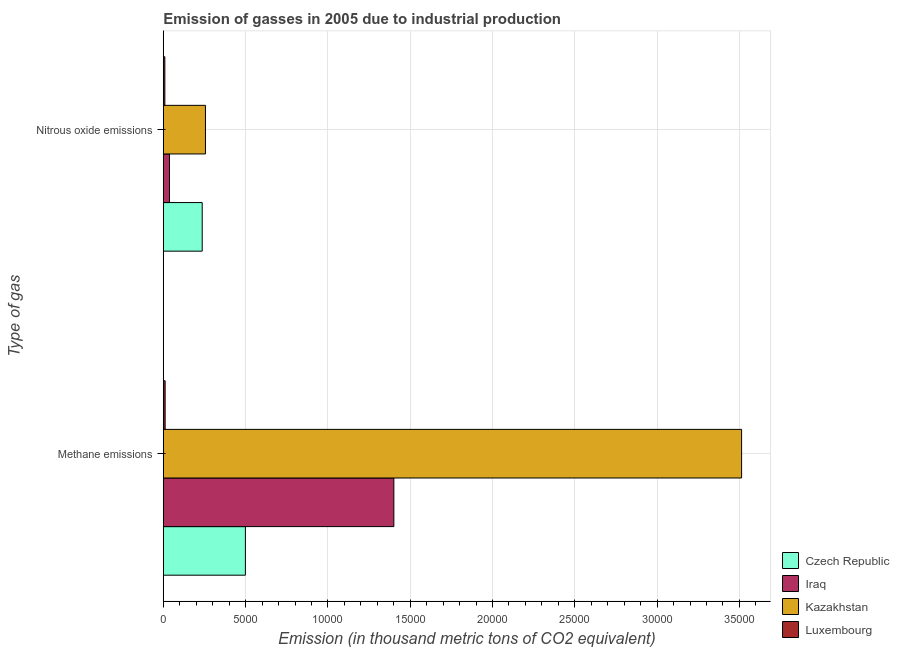How many different coloured bars are there?
Provide a short and direct response. 4. Are the number of bars per tick equal to the number of legend labels?
Keep it short and to the point. Yes. How many bars are there on the 1st tick from the bottom?
Your answer should be compact. 4. What is the label of the 2nd group of bars from the top?
Your response must be concise. Methane emissions. What is the amount of nitrous oxide emissions in Kazakhstan?
Offer a very short reply. 2561.2. Across all countries, what is the maximum amount of nitrous oxide emissions?
Offer a very short reply. 2561.2. Across all countries, what is the minimum amount of nitrous oxide emissions?
Keep it short and to the point. 93.4. In which country was the amount of methane emissions maximum?
Offer a terse response. Kazakhstan. In which country was the amount of nitrous oxide emissions minimum?
Offer a very short reply. Luxembourg. What is the total amount of methane emissions in the graph?
Give a very brief answer. 5.42e+04. What is the difference between the amount of nitrous oxide emissions in Kazakhstan and that in Luxembourg?
Ensure brevity in your answer.  2467.8. What is the difference between the amount of methane emissions in Czech Republic and the amount of nitrous oxide emissions in Kazakhstan?
Make the answer very short. 2425.7. What is the average amount of nitrous oxide emissions per country?
Provide a succinct answer. 1348.65. What is the difference between the amount of nitrous oxide emissions and amount of methane emissions in Czech Republic?
Offer a very short reply. -2622.4. In how many countries, is the amount of nitrous oxide emissions greater than 33000 thousand metric tons?
Ensure brevity in your answer.  0. What is the ratio of the amount of nitrous oxide emissions in Iraq to that in Kazakhstan?
Give a very brief answer. 0.15. Is the amount of nitrous oxide emissions in Kazakhstan less than that in Luxembourg?
Give a very brief answer. No. What does the 4th bar from the top in Nitrous oxide emissions represents?
Offer a terse response. Czech Republic. What does the 2nd bar from the bottom in Nitrous oxide emissions represents?
Your answer should be compact. Iraq. What is the difference between two consecutive major ticks on the X-axis?
Provide a succinct answer. 5000. Are the values on the major ticks of X-axis written in scientific E-notation?
Give a very brief answer. No. Does the graph contain any zero values?
Give a very brief answer. No. Where does the legend appear in the graph?
Offer a terse response. Bottom right. How many legend labels are there?
Ensure brevity in your answer.  4. How are the legend labels stacked?
Make the answer very short. Vertical. What is the title of the graph?
Offer a terse response. Emission of gasses in 2005 due to industrial production. Does "Somalia" appear as one of the legend labels in the graph?
Make the answer very short. No. What is the label or title of the X-axis?
Your answer should be compact. Emission (in thousand metric tons of CO2 equivalent). What is the label or title of the Y-axis?
Offer a terse response. Type of gas. What is the Emission (in thousand metric tons of CO2 equivalent) of Czech Republic in Methane emissions?
Keep it short and to the point. 4986.9. What is the Emission (in thousand metric tons of CO2 equivalent) of Iraq in Methane emissions?
Your response must be concise. 1.40e+04. What is the Emission (in thousand metric tons of CO2 equivalent) of Kazakhstan in Methane emissions?
Your answer should be compact. 3.51e+04. What is the Emission (in thousand metric tons of CO2 equivalent) of Luxembourg in Methane emissions?
Make the answer very short. 111.5. What is the Emission (in thousand metric tons of CO2 equivalent) of Czech Republic in Nitrous oxide emissions?
Offer a very short reply. 2364.5. What is the Emission (in thousand metric tons of CO2 equivalent) of Iraq in Nitrous oxide emissions?
Your response must be concise. 375.5. What is the Emission (in thousand metric tons of CO2 equivalent) in Kazakhstan in Nitrous oxide emissions?
Provide a succinct answer. 2561.2. What is the Emission (in thousand metric tons of CO2 equivalent) in Luxembourg in Nitrous oxide emissions?
Provide a succinct answer. 93.4. Across all Type of gas, what is the maximum Emission (in thousand metric tons of CO2 equivalent) of Czech Republic?
Offer a very short reply. 4986.9. Across all Type of gas, what is the maximum Emission (in thousand metric tons of CO2 equivalent) in Iraq?
Offer a terse response. 1.40e+04. Across all Type of gas, what is the maximum Emission (in thousand metric tons of CO2 equivalent) in Kazakhstan?
Make the answer very short. 3.51e+04. Across all Type of gas, what is the maximum Emission (in thousand metric tons of CO2 equivalent) in Luxembourg?
Offer a terse response. 111.5. Across all Type of gas, what is the minimum Emission (in thousand metric tons of CO2 equivalent) of Czech Republic?
Your answer should be very brief. 2364.5. Across all Type of gas, what is the minimum Emission (in thousand metric tons of CO2 equivalent) in Iraq?
Your answer should be compact. 375.5. Across all Type of gas, what is the minimum Emission (in thousand metric tons of CO2 equivalent) of Kazakhstan?
Offer a terse response. 2561.2. Across all Type of gas, what is the minimum Emission (in thousand metric tons of CO2 equivalent) in Luxembourg?
Make the answer very short. 93.4. What is the total Emission (in thousand metric tons of CO2 equivalent) of Czech Republic in the graph?
Your response must be concise. 7351.4. What is the total Emission (in thousand metric tons of CO2 equivalent) of Iraq in the graph?
Make the answer very short. 1.44e+04. What is the total Emission (in thousand metric tons of CO2 equivalent) in Kazakhstan in the graph?
Offer a terse response. 3.77e+04. What is the total Emission (in thousand metric tons of CO2 equivalent) of Luxembourg in the graph?
Make the answer very short. 204.9. What is the difference between the Emission (in thousand metric tons of CO2 equivalent) in Czech Republic in Methane emissions and that in Nitrous oxide emissions?
Offer a terse response. 2622.4. What is the difference between the Emission (in thousand metric tons of CO2 equivalent) of Iraq in Methane emissions and that in Nitrous oxide emissions?
Your answer should be compact. 1.36e+04. What is the difference between the Emission (in thousand metric tons of CO2 equivalent) of Kazakhstan in Methane emissions and that in Nitrous oxide emissions?
Offer a very short reply. 3.26e+04. What is the difference between the Emission (in thousand metric tons of CO2 equivalent) in Czech Republic in Methane emissions and the Emission (in thousand metric tons of CO2 equivalent) in Iraq in Nitrous oxide emissions?
Your response must be concise. 4611.4. What is the difference between the Emission (in thousand metric tons of CO2 equivalent) of Czech Republic in Methane emissions and the Emission (in thousand metric tons of CO2 equivalent) of Kazakhstan in Nitrous oxide emissions?
Provide a short and direct response. 2425.7. What is the difference between the Emission (in thousand metric tons of CO2 equivalent) in Czech Republic in Methane emissions and the Emission (in thousand metric tons of CO2 equivalent) in Luxembourg in Nitrous oxide emissions?
Provide a succinct answer. 4893.5. What is the difference between the Emission (in thousand metric tons of CO2 equivalent) of Iraq in Methane emissions and the Emission (in thousand metric tons of CO2 equivalent) of Kazakhstan in Nitrous oxide emissions?
Provide a short and direct response. 1.14e+04. What is the difference between the Emission (in thousand metric tons of CO2 equivalent) in Iraq in Methane emissions and the Emission (in thousand metric tons of CO2 equivalent) in Luxembourg in Nitrous oxide emissions?
Your answer should be very brief. 1.39e+04. What is the difference between the Emission (in thousand metric tons of CO2 equivalent) in Kazakhstan in Methane emissions and the Emission (in thousand metric tons of CO2 equivalent) in Luxembourg in Nitrous oxide emissions?
Your answer should be compact. 3.50e+04. What is the average Emission (in thousand metric tons of CO2 equivalent) of Czech Republic per Type of gas?
Your answer should be very brief. 3675.7. What is the average Emission (in thousand metric tons of CO2 equivalent) of Iraq per Type of gas?
Provide a succinct answer. 7190.6. What is the average Emission (in thousand metric tons of CO2 equivalent) in Kazakhstan per Type of gas?
Provide a short and direct response. 1.88e+04. What is the average Emission (in thousand metric tons of CO2 equivalent) of Luxembourg per Type of gas?
Your answer should be compact. 102.45. What is the difference between the Emission (in thousand metric tons of CO2 equivalent) in Czech Republic and Emission (in thousand metric tons of CO2 equivalent) in Iraq in Methane emissions?
Ensure brevity in your answer.  -9018.8. What is the difference between the Emission (in thousand metric tons of CO2 equivalent) of Czech Republic and Emission (in thousand metric tons of CO2 equivalent) of Kazakhstan in Methane emissions?
Provide a succinct answer. -3.01e+04. What is the difference between the Emission (in thousand metric tons of CO2 equivalent) of Czech Republic and Emission (in thousand metric tons of CO2 equivalent) of Luxembourg in Methane emissions?
Provide a succinct answer. 4875.4. What is the difference between the Emission (in thousand metric tons of CO2 equivalent) in Iraq and Emission (in thousand metric tons of CO2 equivalent) in Kazakhstan in Methane emissions?
Your answer should be compact. -2.11e+04. What is the difference between the Emission (in thousand metric tons of CO2 equivalent) of Iraq and Emission (in thousand metric tons of CO2 equivalent) of Luxembourg in Methane emissions?
Your answer should be very brief. 1.39e+04. What is the difference between the Emission (in thousand metric tons of CO2 equivalent) in Kazakhstan and Emission (in thousand metric tons of CO2 equivalent) in Luxembourg in Methane emissions?
Make the answer very short. 3.50e+04. What is the difference between the Emission (in thousand metric tons of CO2 equivalent) in Czech Republic and Emission (in thousand metric tons of CO2 equivalent) in Iraq in Nitrous oxide emissions?
Your answer should be compact. 1989. What is the difference between the Emission (in thousand metric tons of CO2 equivalent) in Czech Republic and Emission (in thousand metric tons of CO2 equivalent) in Kazakhstan in Nitrous oxide emissions?
Your answer should be very brief. -196.7. What is the difference between the Emission (in thousand metric tons of CO2 equivalent) of Czech Republic and Emission (in thousand metric tons of CO2 equivalent) of Luxembourg in Nitrous oxide emissions?
Give a very brief answer. 2271.1. What is the difference between the Emission (in thousand metric tons of CO2 equivalent) in Iraq and Emission (in thousand metric tons of CO2 equivalent) in Kazakhstan in Nitrous oxide emissions?
Offer a terse response. -2185.7. What is the difference between the Emission (in thousand metric tons of CO2 equivalent) of Iraq and Emission (in thousand metric tons of CO2 equivalent) of Luxembourg in Nitrous oxide emissions?
Your answer should be very brief. 282.1. What is the difference between the Emission (in thousand metric tons of CO2 equivalent) in Kazakhstan and Emission (in thousand metric tons of CO2 equivalent) in Luxembourg in Nitrous oxide emissions?
Your answer should be compact. 2467.8. What is the ratio of the Emission (in thousand metric tons of CO2 equivalent) of Czech Republic in Methane emissions to that in Nitrous oxide emissions?
Ensure brevity in your answer.  2.11. What is the ratio of the Emission (in thousand metric tons of CO2 equivalent) of Iraq in Methane emissions to that in Nitrous oxide emissions?
Provide a succinct answer. 37.3. What is the ratio of the Emission (in thousand metric tons of CO2 equivalent) of Kazakhstan in Methane emissions to that in Nitrous oxide emissions?
Your response must be concise. 13.72. What is the ratio of the Emission (in thousand metric tons of CO2 equivalent) in Luxembourg in Methane emissions to that in Nitrous oxide emissions?
Ensure brevity in your answer.  1.19. What is the difference between the highest and the second highest Emission (in thousand metric tons of CO2 equivalent) in Czech Republic?
Your answer should be compact. 2622.4. What is the difference between the highest and the second highest Emission (in thousand metric tons of CO2 equivalent) of Iraq?
Your response must be concise. 1.36e+04. What is the difference between the highest and the second highest Emission (in thousand metric tons of CO2 equivalent) of Kazakhstan?
Your answer should be very brief. 3.26e+04. What is the difference between the highest and the lowest Emission (in thousand metric tons of CO2 equivalent) in Czech Republic?
Provide a succinct answer. 2622.4. What is the difference between the highest and the lowest Emission (in thousand metric tons of CO2 equivalent) in Iraq?
Give a very brief answer. 1.36e+04. What is the difference between the highest and the lowest Emission (in thousand metric tons of CO2 equivalent) in Kazakhstan?
Give a very brief answer. 3.26e+04. 